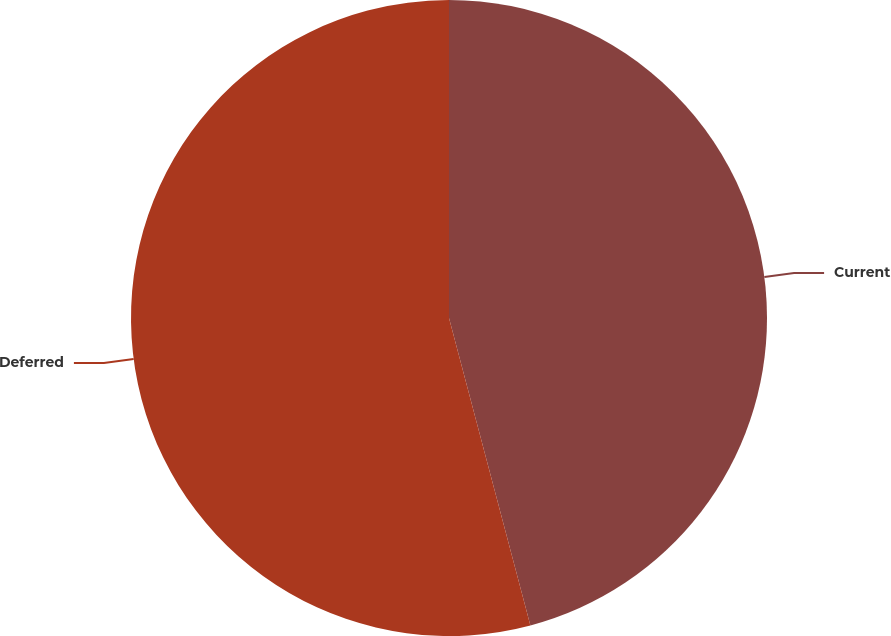Convert chart to OTSL. <chart><loc_0><loc_0><loc_500><loc_500><pie_chart><fcel>Current<fcel>Deferred<nl><fcel>45.88%<fcel>54.12%<nl></chart> 